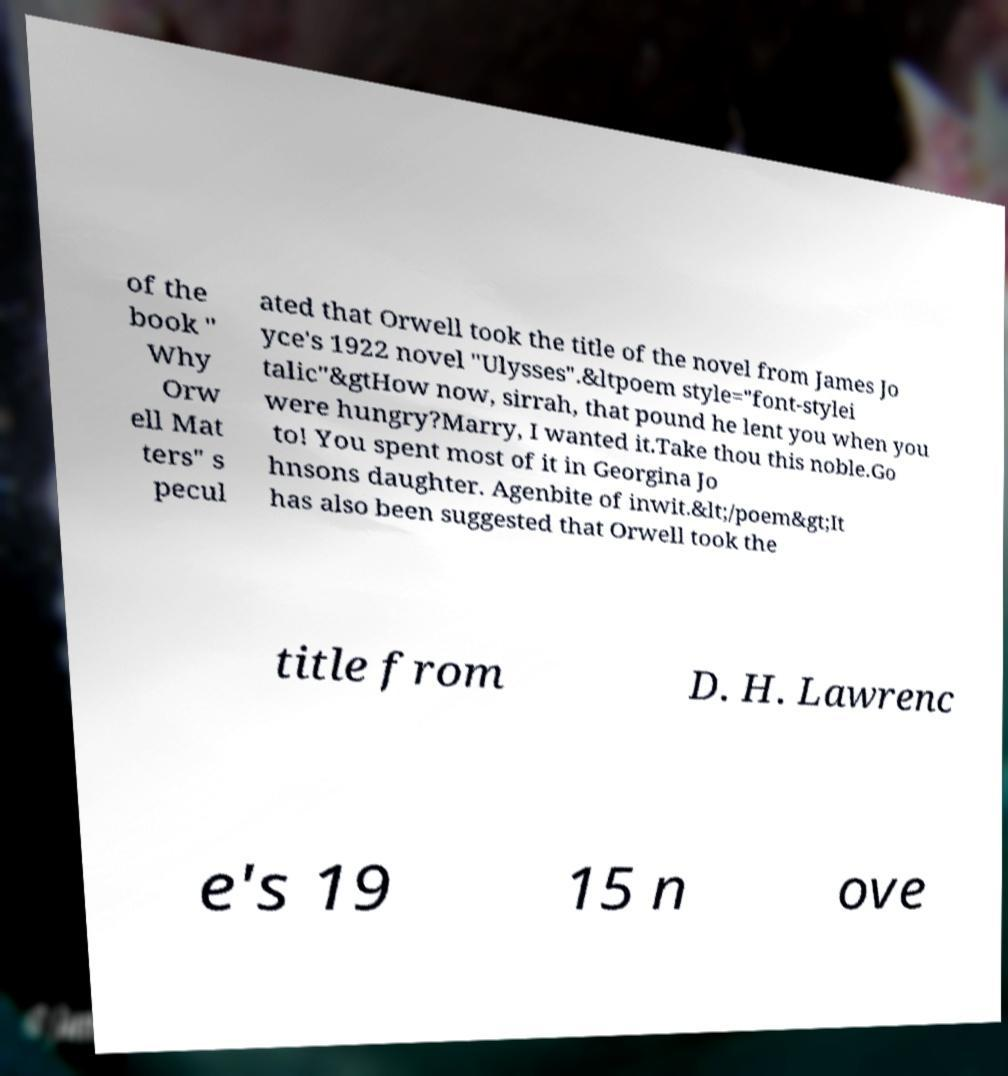Can you read and provide the text displayed in the image?This photo seems to have some interesting text. Can you extract and type it out for me? of the book " Why Orw ell Mat ters" s pecul ated that Orwell took the title of the novel from James Jo yce's 1922 novel "Ulysses".&ltpoem style="font-stylei talic"&gtHow now, sirrah, that pound he lent you when you were hungry?Marry, I wanted it.Take thou this noble.Go to! You spent most of it in Georgina Jo hnsons daughter. Agenbite of inwit.&lt;/poem&gt;It has also been suggested that Orwell took the title from D. H. Lawrenc e's 19 15 n ove 